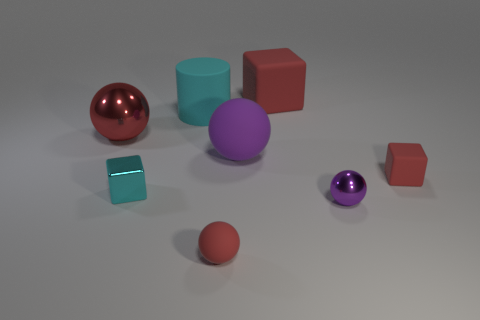There is a big red object left of the small red thing in front of the cyan metallic object; are there any red balls in front of it?
Offer a very short reply. Yes. There is a big cylinder; how many small blocks are on the left side of it?
Your answer should be compact. 1. What number of objects have the same color as the big cube?
Your answer should be very brief. 3. How many objects are tiny red things left of the small purple sphere or large red things that are in front of the cyan matte cylinder?
Give a very brief answer. 2. Are there more shiny cubes than cyan matte cubes?
Your response must be concise. Yes. What color is the ball that is behind the purple rubber sphere?
Provide a short and direct response. Red. Is the purple rubber thing the same shape as the big cyan matte thing?
Make the answer very short. No. The small thing that is both in front of the tiny cyan metal thing and to the left of the purple rubber ball is what color?
Offer a terse response. Red. There is a metal object behind the cyan metal thing; is its size the same as the cyan cylinder that is behind the small red block?
Keep it short and to the point. Yes. How many objects are tiny objects that are left of the big rubber cylinder or big brown matte balls?
Provide a short and direct response. 1. 